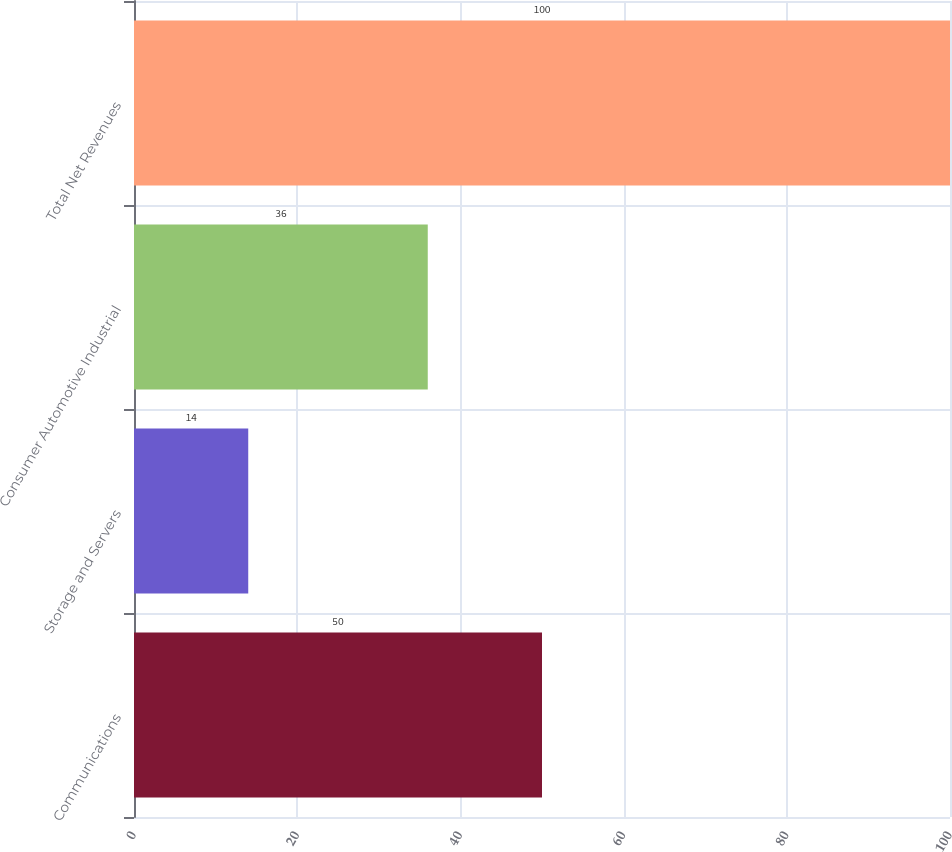<chart> <loc_0><loc_0><loc_500><loc_500><bar_chart><fcel>Communications<fcel>Storage and Servers<fcel>Consumer Automotive Industrial<fcel>Total Net Revenues<nl><fcel>50<fcel>14<fcel>36<fcel>100<nl></chart> 